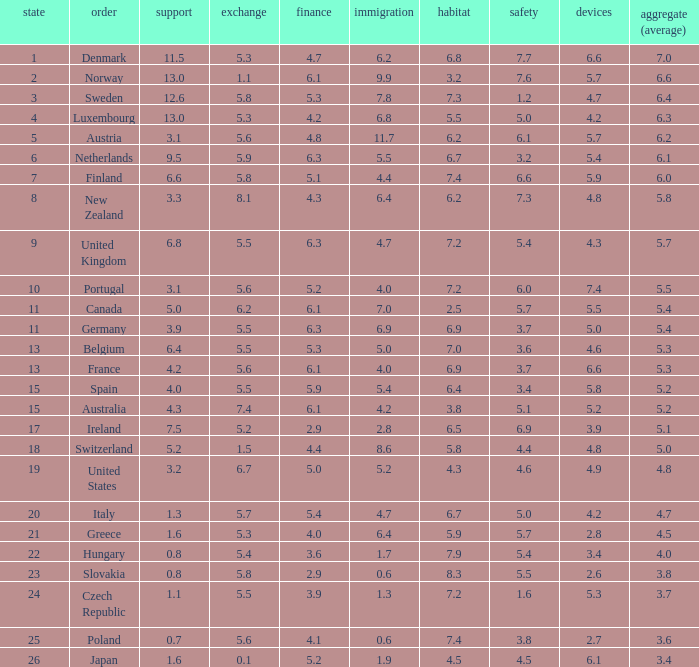How many times is denmark ranked in technology? 1.0. Could you parse the entire table? {'header': ['state', 'order', 'support', 'exchange', 'finance', 'immigration', 'habitat', 'safety', 'devices', 'aggregate (average)'], 'rows': [['1', 'Denmark', '11.5', '5.3', '4.7', '6.2', '6.8', '7.7', '6.6', '7.0'], ['2', 'Norway', '13.0', '1.1', '6.1', '9.9', '3.2', '7.6', '5.7', '6.6'], ['3', 'Sweden', '12.6', '5.8', '5.3', '7.8', '7.3', '1.2', '4.7', '6.4'], ['4', 'Luxembourg', '13.0', '5.3', '4.2', '6.8', '5.5', '5.0', '4.2', '6.3'], ['5', 'Austria', '3.1', '5.6', '4.8', '11.7', '6.2', '6.1', '5.7', '6.2'], ['6', 'Netherlands', '9.5', '5.9', '6.3', '5.5', '6.7', '3.2', '5.4', '6.1'], ['7', 'Finland', '6.6', '5.8', '5.1', '4.4', '7.4', '6.6', '5.9', '6.0'], ['8', 'New Zealand', '3.3', '8.1', '4.3', '6.4', '6.2', '7.3', '4.8', '5.8'], ['9', 'United Kingdom', '6.8', '5.5', '6.3', '4.7', '7.2', '5.4', '4.3', '5.7'], ['10', 'Portugal', '3.1', '5.6', '5.2', '4.0', '7.2', '6.0', '7.4', '5.5'], ['11', 'Canada', '5.0', '6.2', '6.1', '7.0', '2.5', '5.7', '5.5', '5.4'], ['11', 'Germany', '3.9', '5.5', '6.3', '6.9', '6.9', '3.7', '5.0', '5.4'], ['13', 'Belgium', '6.4', '5.5', '5.3', '5.0', '7.0', '3.6', '4.6', '5.3'], ['13', 'France', '4.2', '5.6', '6.1', '4.0', '6.9', '3.7', '6.6', '5.3'], ['15', 'Spain', '4.0', '5.5', '5.9', '5.4', '6.4', '3.4', '5.8', '5.2'], ['15', 'Australia', '4.3', '7.4', '6.1', '4.2', '3.8', '5.1', '5.2', '5.2'], ['17', 'Ireland', '7.5', '5.2', '2.9', '2.8', '6.5', '6.9', '3.9', '5.1'], ['18', 'Switzerland', '5.2', '1.5', '4.4', '8.6', '5.8', '4.4', '4.8', '5.0'], ['19', 'United States', '3.2', '6.7', '5.0', '5.2', '4.3', '4.6', '4.9', '4.8'], ['20', 'Italy', '1.3', '5.7', '5.4', '4.7', '6.7', '5.0', '4.2', '4.7'], ['21', 'Greece', '1.6', '5.3', '4.0', '6.4', '5.9', '5.7', '2.8', '4.5'], ['22', 'Hungary', '0.8', '5.4', '3.6', '1.7', '7.9', '5.4', '3.4', '4.0'], ['23', 'Slovakia', '0.8', '5.8', '2.9', '0.6', '8.3', '5.5', '2.6', '3.8'], ['24', 'Czech Republic', '1.1', '5.5', '3.9', '1.3', '7.2', '1.6', '5.3', '3.7'], ['25', 'Poland', '0.7', '5.6', '4.1', '0.6', '7.4', '3.8', '2.7', '3.6'], ['26', 'Japan', '1.6', '0.1', '5.2', '1.9', '4.5', '4.5', '6.1', '3.4']]} 